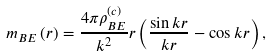<formula> <loc_0><loc_0><loc_500><loc_500>m _ { B E } \left ( r \right ) = \frac { 4 \pi \rho _ { B E } ^ { ( c ) } } { k ^ { 2 } } r \left ( \frac { \sin k r } { k r } - \cos k r \right ) ,</formula> 